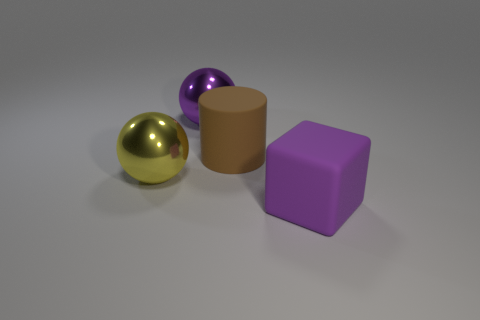There is a sphere that is left of the purple metal ball that is behind the ball in front of the large rubber cylinder; what is its size?
Provide a short and direct response. Large. Is the number of rubber cubes less than the number of tiny red matte cubes?
Provide a short and direct response. No. The other large object that is the same shape as the big purple metal object is what color?
Provide a succinct answer. Yellow. Are there any metal things in front of the large purple object in front of the purple object that is left of the purple rubber object?
Give a very brief answer. No. Do the purple matte object and the big brown matte object have the same shape?
Your response must be concise. No. Are there fewer purple matte cubes that are behind the brown thing than small gray metallic spheres?
Your answer should be compact. No. There is a big object behind the big rubber object behind the metallic ball that is in front of the large purple metal object; what color is it?
Your answer should be very brief. Purple. What number of matte things are either brown cylinders or cubes?
Keep it short and to the point. 2. Is the block the same size as the purple shiny object?
Offer a very short reply. Yes. Are there fewer big shiny balls that are in front of the yellow ball than large brown objects that are in front of the big purple rubber thing?
Your answer should be compact. No. 